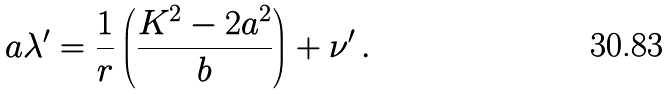Convert formula to latex. <formula><loc_0><loc_0><loc_500><loc_500>a \lambda ^ { \prime } = \frac { 1 } { r } \left ( \frac { K ^ { 2 } - 2 a ^ { 2 } } { b } \right ) + \nu ^ { \prime } \, .</formula> 